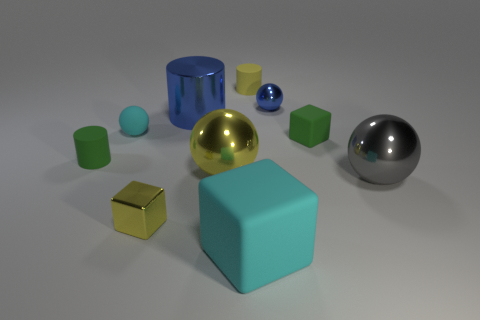Subtract all cylinders. How many objects are left? 7 Add 9 yellow blocks. How many yellow blocks are left? 10 Add 3 tiny blue balls. How many tiny blue balls exist? 4 Subtract 0 blue blocks. How many objects are left? 10 Subtract all yellow cylinders. Subtract all small matte spheres. How many objects are left? 8 